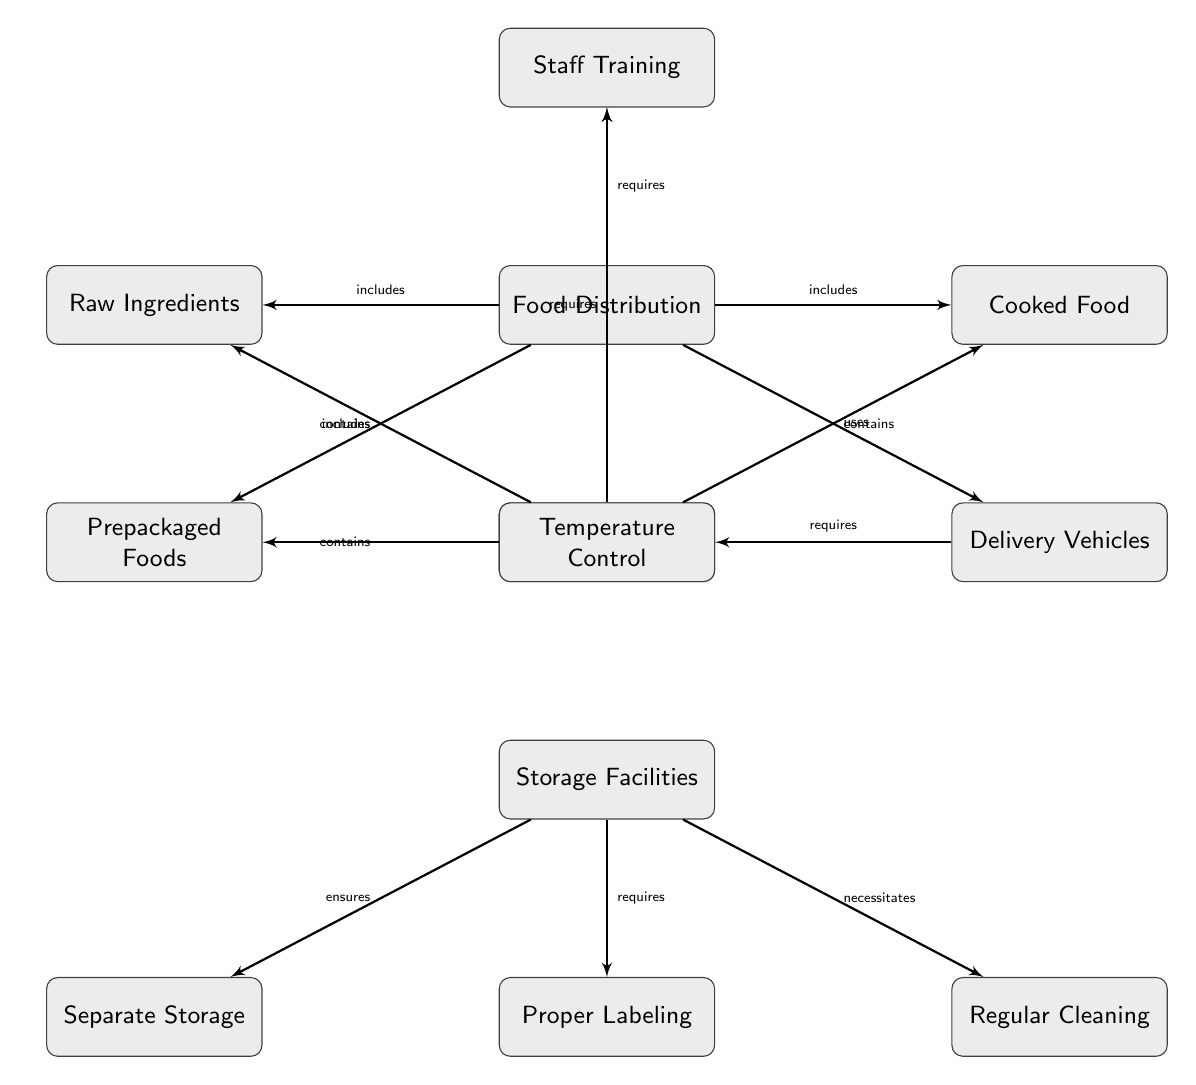What are the nodes included in Food Distribution? The node labeled "Food Distribution" has edges connecting to three nodes: "Raw Ingredients," "Cooked Food," and "Prepackaged Foods." Therefore, these three nodes are included in Food Distribution.
Answer: Raw Ingredients, Cooked Food, Prepackaged Foods Which node requires Temperature Control? The node "Delivery Vehicles" has an edge leading to "Temperature Control," indicating that it requires temperature control for safe food distribution.
Answer: Delivery Vehicles What does Storage Facilities ensure? The node "Storage Facilities" is connected to "Separate Storage," indicating that it ensures separate storage of food items to prevent cross-contamination.
Answer: Separate Storage How many edges are connected to Food Storage? The node "Food Storage" has three edges connecting it to "Raw Ingredients," "Cooked Food," and "Prepackaged Foods." Thus, there are three edges connected to Food Storage.
Answer: 3 What are the two requirements for Storage Facilities? The edges from "Storage Facilities" lead to three nodes: "Separate Storage," "Proper Labeling," and "Regular Cleaning." Therefore, it has the requirements of separate storage and proper labeling.
Answer: Separate Storage, Proper Labeling Which aspect needs to be addressed by Staff Training in both Food Distribution and Food Storage? The edges from "Food Distribution" and "Food Storage" both connect to the "Staff Training" node, indicating that staff training is a necessary aspect for both processes to prevent cross-contamination.
Answer: Staff Training What do the edges labeled with 'contains' signify in the diagram? The edges connecting "Food Storage" to "Raw Ingredients," "Cooked Food," and "Prepackaged Foods," indicated by the label 'contains,' signify that the storage includes these types of food items.
Answer: Food items What nodes are under Food Storage? The node "Food Storage" connects to three nodes: "Raw Ingredients," "Cooked Food," and "Prepackaged Foods," indicating these are stored within this category.
Answer: Raw Ingredients, Cooked Food, Prepackaged Foods 